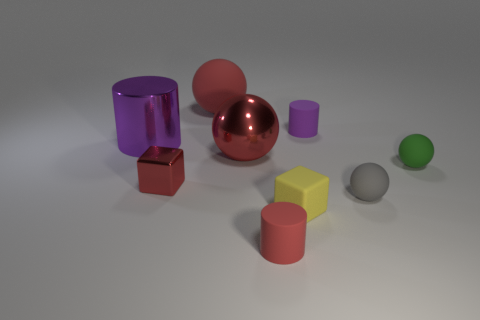The tiny matte thing that is the same color as the tiny metallic cube is what shape?
Your answer should be compact. Cylinder. What size is the red object that is the same shape as the purple matte thing?
Provide a succinct answer. Small. Does the purple thing on the left side of the tiny purple matte thing have the same shape as the small red shiny thing?
Your answer should be very brief. No. What color is the rubber cylinder behind the small red cylinder?
Offer a very short reply. Purple. What number of other objects are there of the same size as the yellow object?
Your answer should be very brief. 5. Is there any other thing that is the same shape as the large purple object?
Give a very brief answer. Yes. Is the number of red things right of the small yellow cube the same as the number of large blue matte cubes?
Offer a very short reply. Yes. How many large objects are the same material as the small green sphere?
Make the answer very short. 1. What is the color of the big thing that is made of the same material as the tiny yellow object?
Ensure brevity in your answer.  Red. Do the tiny yellow matte thing and the small green rubber object have the same shape?
Ensure brevity in your answer.  No. 